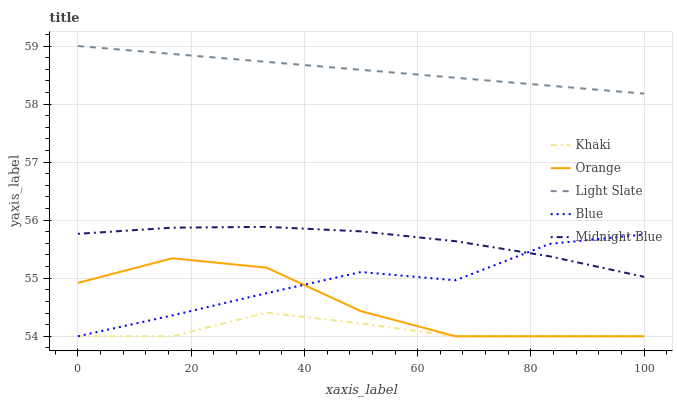Does Light Slate have the minimum area under the curve?
Answer yes or no. No. Does Khaki have the maximum area under the curve?
Answer yes or no. No. Is Khaki the smoothest?
Answer yes or no. No. Is Khaki the roughest?
Answer yes or no. No. Does Light Slate have the lowest value?
Answer yes or no. No. Does Khaki have the highest value?
Answer yes or no. No. Is Orange less than Light Slate?
Answer yes or no. Yes. Is Light Slate greater than Orange?
Answer yes or no. Yes. Does Orange intersect Light Slate?
Answer yes or no. No. 